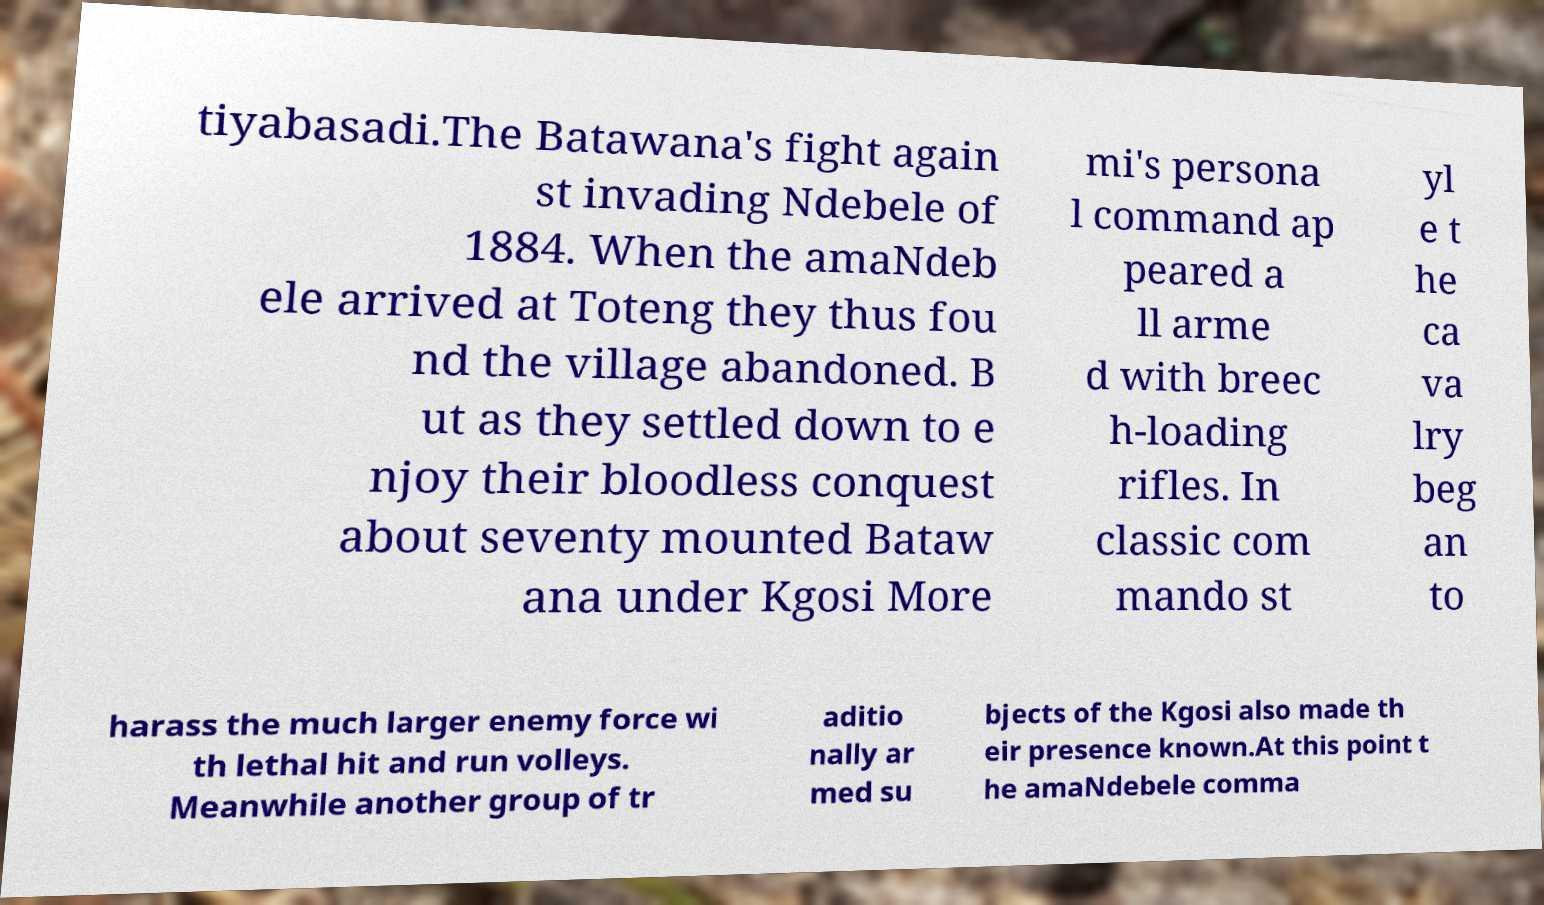Can you read and provide the text displayed in the image?This photo seems to have some interesting text. Can you extract and type it out for me? tiyabasadi.The Batawana's fight again st invading Ndebele of 1884. When the amaNdeb ele arrived at Toteng they thus fou nd the village abandoned. B ut as they settled down to e njoy their bloodless conquest about seventy mounted Bataw ana under Kgosi More mi's persona l command ap peared a ll arme d with breec h-loading rifles. In classic com mando st yl e t he ca va lry beg an to harass the much larger enemy force wi th lethal hit and run volleys. Meanwhile another group of tr aditio nally ar med su bjects of the Kgosi also made th eir presence known.At this point t he amaNdebele comma 